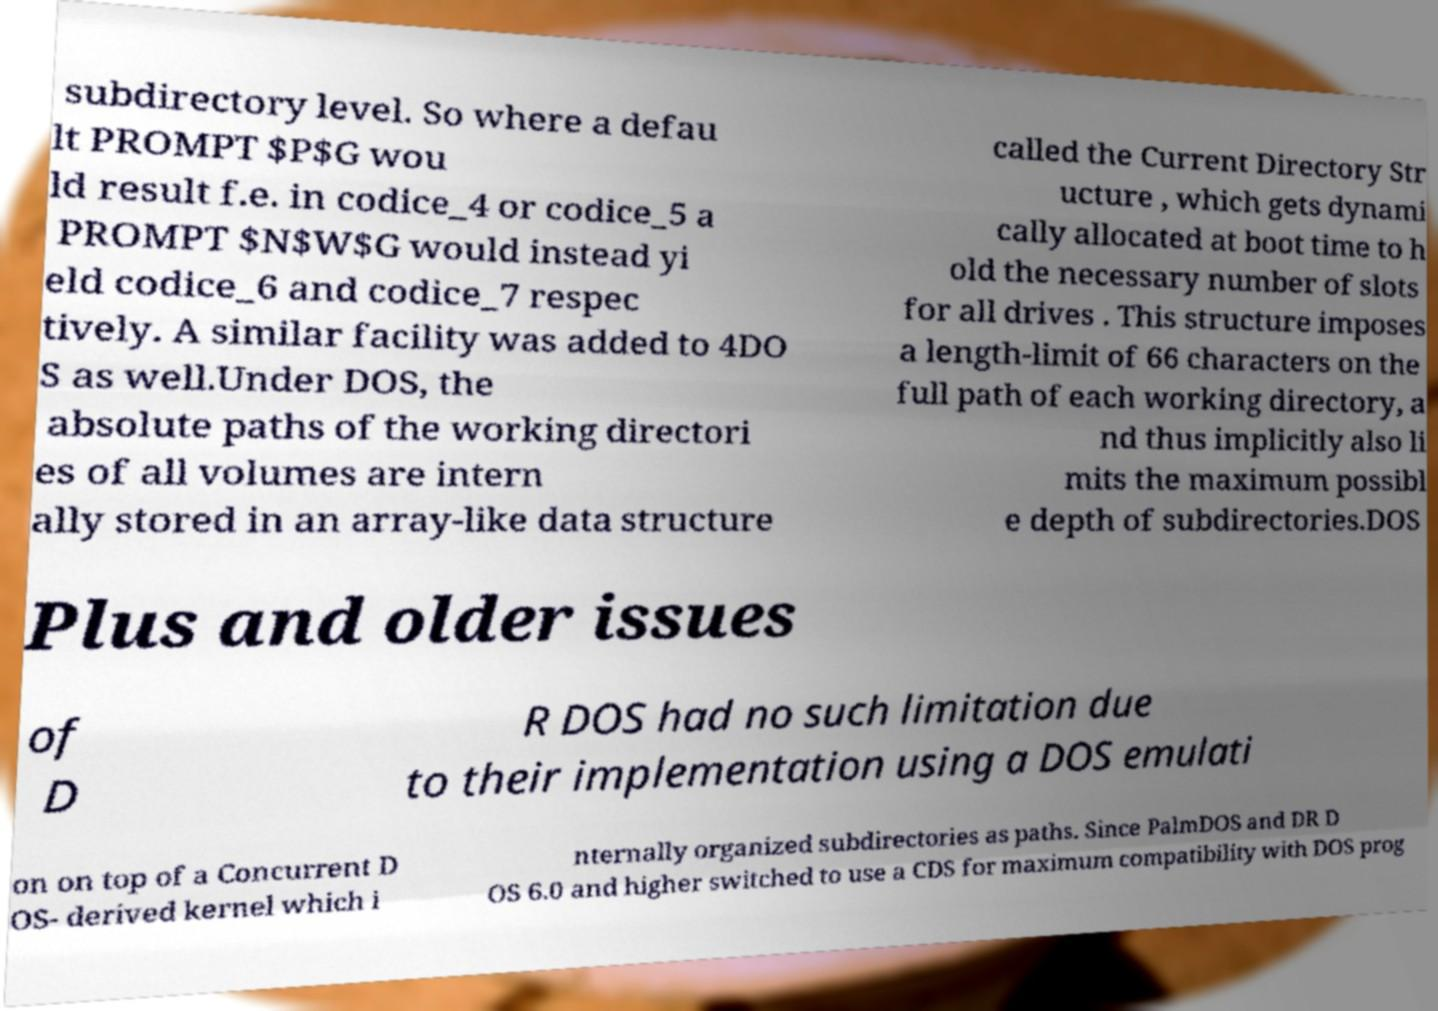There's text embedded in this image that I need extracted. Can you transcribe it verbatim? subdirectory level. So where a defau lt PROMPT $P$G wou ld result f.e. in codice_4 or codice_5 a PROMPT $N$W$G would instead yi eld codice_6 and codice_7 respec tively. A similar facility was added to 4DO S as well.Under DOS, the absolute paths of the working directori es of all volumes are intern ally stored in an array-like data structure called the Current Directory Str ucture , which gets dynami cally allocated at boot time to h old the necessary number of slots for all drives . This structure imposes a length-limit of 66 characters on the full path of each working directory, a nd thus implicitly also li mits the maximum possibl e depth of subdirectories.DOS Plus and older issues of D R DOS had no such limitation due to their implementation using a DOS emulati on on top of a Concurrent D OS- derived kernel which i nternally organized subdirectories as paths. Since PalmDOS and DR D OS 6.0 and higher switched to use a CDS for maximum compatibility with DOS prog 